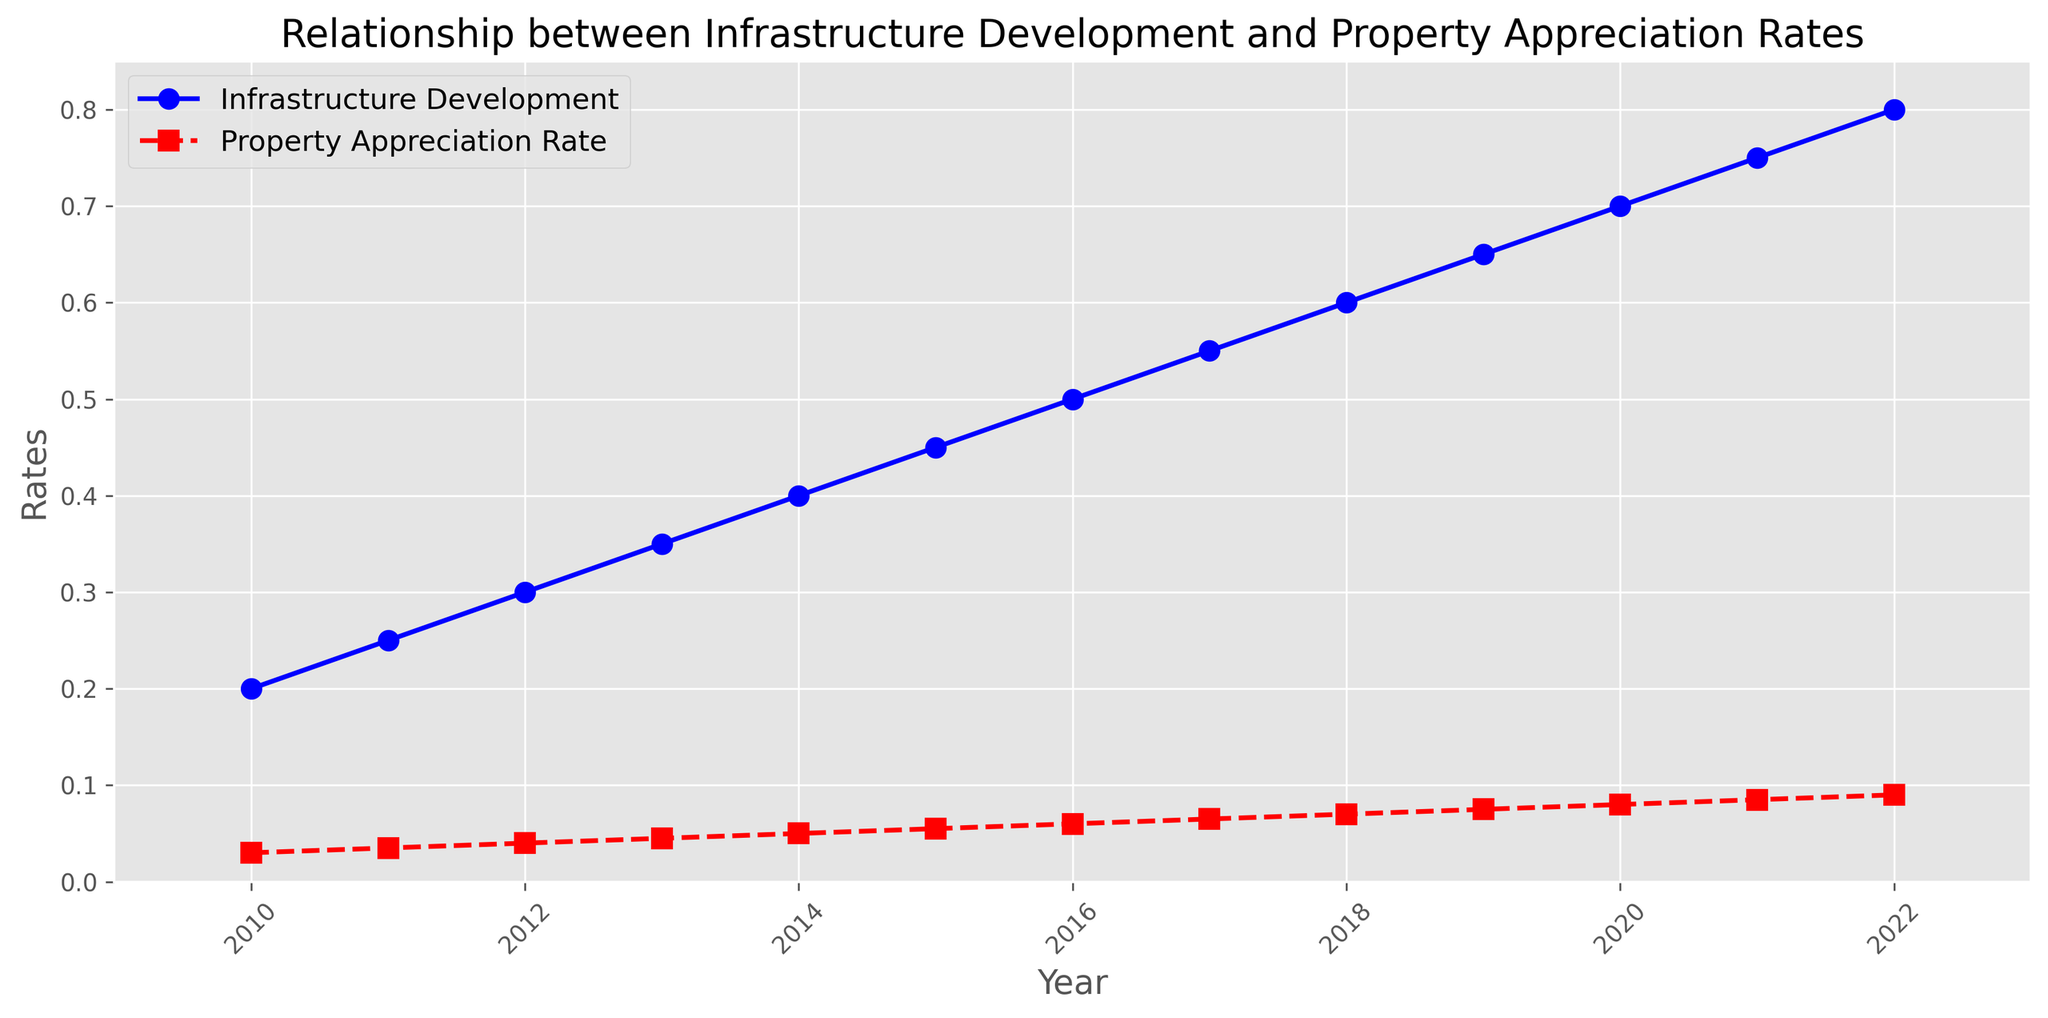What is the rate of infrastructure development in 2015? From the figure, find the point along the Infrastructure Development line that corresponds to the year 2015. The y-value at this point represents the development rate.
Answer: 0.45 How does the property appreciation rate in 2020 compare to that in 2019? Identify the points for 2020 and 2019 along the Property Appreciation Rate line and compare their y-values. The rate in 2020 is higher than in 2019.
Answer: Higher What is the combined rate of infrastructure development for the years 2010 and 2011? Add the y-values of the Infrastructure Development line for the years 2010 and 2011 (0.2 + 0.25).
Answer: 0.45 By how much did the property appreciation rate increase from 2010 to 2022? Find the y-values for Property Appreciation Rate at 2010 and 2022 (0.03 and 0.09, respectively) and compute their difference (0.09 - 0.03).
Answer: 0.06 In which year was the gap between Infrastructure Development and Property Appreciation Rate smallest? By examining the gaps in the figure, identify the year where the distance between the two lines is least noticeable.
Answer: 2010 What is the average property appreciation rate over the entire period shown? Sum up the property appreciation rates for each year (0.03 + 0.035 + ... + 0.09) and divide by the number of years (13).
Answer: 0.057 Which development rate (infrastructure or property appreciation) showed a steeper increase between 2012 and 2013? Calculate the difference between the y-values for both lines (Infrastructure: 0.35 - 0.3 = 0.05, Property: 0.045 - 0.04 = 0.005). Infrastructure's increase is steeper.
Answer: Infrastructure What general trend can be observed for both infrastructure development and property appreciation rates over the years? Looking at both lines, observe that both show a consistent upwards trend year after year.
Answer: Upwards trend How much greater was the infrastructure development rate in 2022 compared to 2010? Calculate the difference between the y-values for infrastructure development for the two years (0.8 - 0.2).
Answer: 0.6 